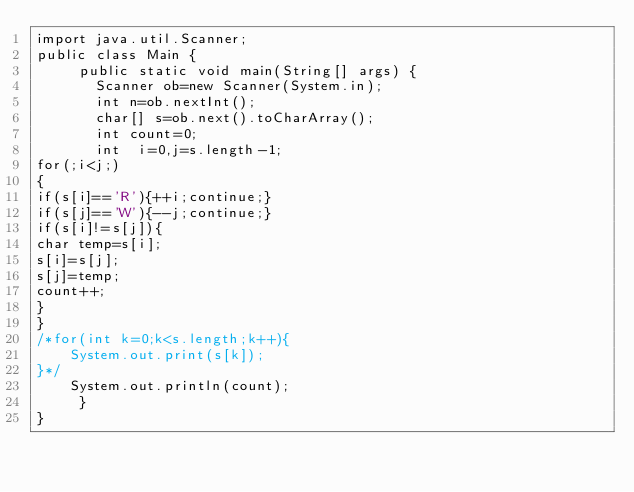<code> <loc_0><loc_0><loc_500><loc_500><_Java_>import java.util.Scanner;
public class Main {
     public static void main(String[] args) {
       Scanner ob=new Scanner(System.in);
       int n=ob.nextInt();
       char[] s=ob.next().toCharArray();
       int count=0;
       int  i=0,j=s.length-1;
for(;i<j;)
{
if(s[i]=='R'){++i;continue;}
if(s[j]=='W'){--j;continue;}
if(s[i]!=s[j]){
char temp=s[i];
s[i]=s[j];
s[j]=temp;
count++;
}
}
/*for(int k=0;k<s.length;k++){
    System.out.print(s[k]);
}*/
    System.out.println(count);
     } 
}</code> 